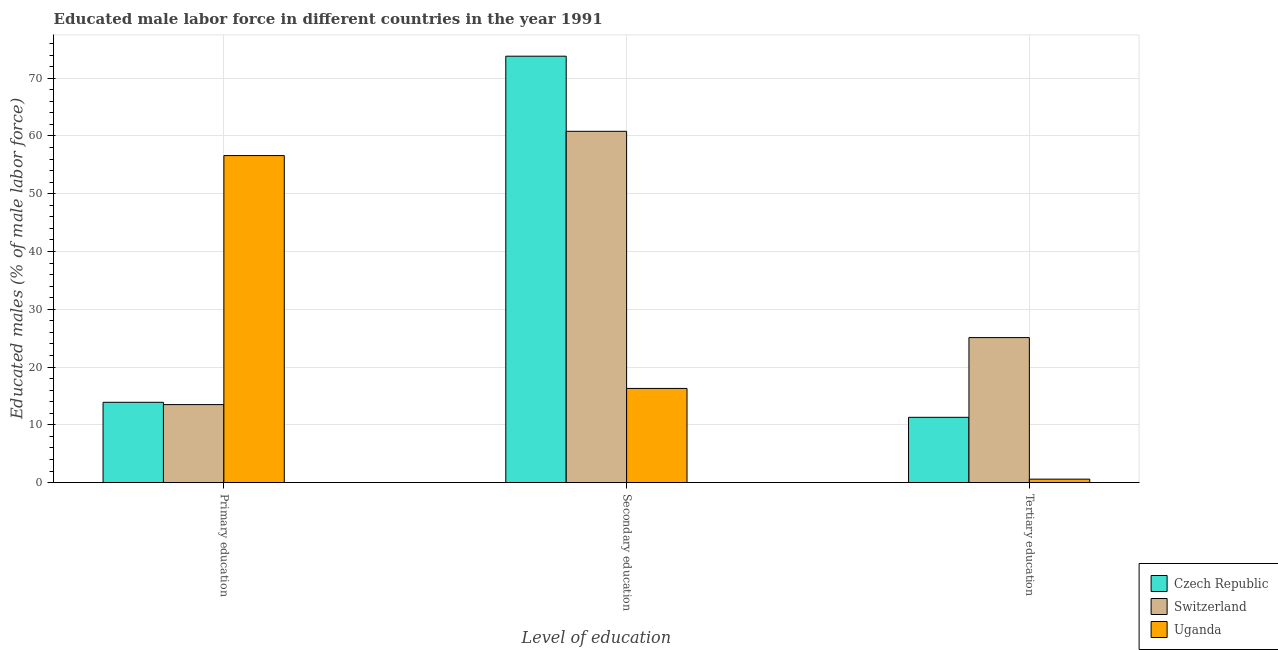Are the number of bars on each tick of the X-axis equal?
Ensure brevity in your answer.  Yes. How many bars are there on the 2nd tick from the right?
Give a very brief answer. 3. What is the label of the 2nd group of bars from the left?
Your answer should be very brief. Secondary education. What is the percentage of male labor force who received secondary education in Switzerland?
Ensure brevity in your answer.  60.8. Across all countries, what is the maximum percentage of male labor force who received tertiary education?
Offer a terse response. 25.1. Across all countries, what is the minimum percentage of male labor force who received tertiary education?
Make the answer very short. 0.6. In which country was the percentage of male labor force who received primary education maximum?
Offer a terse response. Uganda. In which country was the percentage of male labor force who received tertiary education minimum?
Your answer should be very brief. Uganda. What is the total percentage of male labor force who received primary education in the graph?
Give a very brief answer. 84. What is the difference between the percentage of male labor force who received primary education in Uganda and that in Switzerland?
Make the answer very short. 43.1. What is the difference between the percentage of male labor force who received secondary education in Switzerland and the percentage of male labor force who received tertiary education in Czech Republic?
Provide a short and direct response. 49.5. What is the average percentage of male labor force who received tertiary education per country?
Make the answer very short. 12.33. What is the difference between the percentage of male labor force who received secondary education and percentage of male labor force who received primary education in Uganda?
Provide a succinct answer. -40.3. In how many countries, is the percentage of male labor force who received secondary education greater than 6 %?
Your answer should be compact. 3. What is the ratio of the percentage of male labor force who received tertiary education in Czech Republic to that in Uganda?
Give a very brief answer. 18.83. Is the percentage of male labor force who received primary education in Uganda less than that in Czech Republic?
Ensure brevity in your answer.  No. What is the difference between the highest and the second highest percentage of male labor force who received secondary education?
Keep it short and to the point. 13. What is the difference between the highest and the lowest percentage of male labor force who received primary education?
Your answer should be compact. 43.1. Is the sum of the percentage of male labor force who received tertiary education in Uganda and Czech Republic greater than the maximum percentage of male labor force who received secondary education across all countries?
Your response must be concise. No. What does the 3rd bar from the left in Tertiary education represents?
Keep it short and to the point. Uganda. What does the 1st bar from the right in Primary education represents?
Your answer should be compact. Uganda. Is it the case that in every country, the sum of the percentage of male labor force who received primary education and percentage of male labor force who received secondary education is greater than the percentage of male labor force who received tertiary education?
Offer a terse response. Yes. How many bars are there?
Make the answer very short. 9. Are the values on the major ticks of Y-axis written in scientific E-notation?
Ensure brevity in your answer.  No. Does the graph contain grids?
Keep it short and to the point. Yes. Where does the legend appear in the graph?
Make the answer very short. Bottom right. How many legend labels are there?
Provide a succinct answer. 3. What is the title of the graph?
Offer a very short reply. Educated male labor force in different countries in the year 1991. Does "Euro area" appear as one of the legend labels in the graph?
Provide a succinct answer. No. What is the label or title of the X-axis?
Offer a very short reply. Level of education. What is the label or title of the Y-axis?
Your answer should be compact. Educated males (% of male labor force). What is the Educated males (% of male labor force) of Czech Republic in Primary education?
Offer a terse response. 13.9. What is the Educated males (% of male labor force) in Switzerland in Primary education?
Provide a short and direct response. 13.5. What is the Educated males (% of male labor force) of Uganda in Primary education?
Your answer should be very brief. 56.6. What is the Educated males (% of male labor force) in Czech Republic in Secondary education?
Your response must be concise. 73.8. What is the Educated males (% of male labor force) in Switzerland in Secondary education?
Make the answer very short. 60.8. What is the Educated males (% of male labor force) of Uganda in Secondary education?
Provide a short and direct response. 16.3. What is the Educated males (% of male labor force) of Czech Republic in Tertiary education?
Your response must be concise. 11.3. What is the Educated males (% of male labor force) in Switzerland in Tertiary education?
Make the answer very short. 25.1. What is the Educated males (% of male labor force) of Uganda in Tertiary education?
Ensure brevity in your answer.  0.6. Across all Level of education, what is the maximum Educated males (% of male labor force) of Czech Republic?
Provide a short and direct response. 73.8. Across all Level of education, what is the maximum Educated males (% of male labor force) in Switzerland?
Keep it short and to the point. 60.8. Across all Level of education, what is the maximum Educated males (% of male labor force) in Uganda?
Provide a short and direct response. 56.6. Across all Level of education, what is the minimum Educated males (% of male labor force) in Czech Republic?
Ensure brevity in your answer.  11.3. Across all Level of education, what is the minimum Educated males (% of male labor force) of Uganda?
Provide a succinct answer. 0.6. What is the total Educated males (% of male labor force) in Switzerland in the graph?
Your response must be concise. 99.4. What is the total Educated males (% of male labor force) in Uganda in the graph?
Offer a terse response. 73.5. What is the difference between the Educated males (% of male labor force) in Czech Republic in Primary education and that in Secondary education?
Your response must be concise. -59.9. What is the difference between the Educated males (% of male labor force) of Switzerland in Primary education and that in Secondary education?
Offer a terse response. -47.3. What is the difference between the Educated males (% of male labor force) of Uganda in Primary education and that in Secondary education?
Offer a very short reply. 40.3. What is the difference between the Educated males (% of male labor force) in Switzerland in Primary education and that in Tertiary education?
Provide a succinct answer. -11.6. What is the difference between the Educated males (% of male labor force) in Uganda in Primary education and that in Tertiary education?
Provide a short and direct response. 56. What is the difference between the Educated males (% of male labor force) in Czech Republic in Secondary education and that in Tertiary education?
Keep it short and to the point. 62.5. What is the difference between the Educated males (% of male labor force) in Switzerland in Secondary education and that in Tertiary education?
Keep it short and to the point. 35.7. What is the difference between the Educated males (% of male labor force) in Uganda in Secondary education and that in Tertiary education?
Give a very brief answer. 15.7. What is the difference between the Educated males (% of male labor force) in Czech Republic in Primary education and the Educated males (% of male labor force) in Switzerland in Secondary education?
Keep it short and to the point. -46.9. What is the difference between the Educated males (% of male labor force) in Switzerland in Primary education and the Educated males (% of male labor force) in Uganda in Secondary education?
Your answer should be very brief. -2.8. What is the difference between the Educated males (% of male labor force) of Czech Republic in Primary education and the Educated males (% of male labor force) of Switzerland in Tertiary education?
Your answer should be very brief. -11.2. What is the difference between the Educated males (% of male labor force) in Czech Republic in Secondary education and the Educated males (% of male labor force) in Switzerland in Tertiary education?
Offer a very short reply. 48.7. What is the difference between the Educated males (% of male labor force) of Czech Republic in Secondary education and the Educated males (% of male labor force) of Uganda in Tertiary education?
Provide a succinct answer. 73.2. What is the difference between the Educated males (% of male labor force) in Switzerland in Secondary education and the Educated males (% of male labor force) in Uganda in Tertiary education?
Keep it short and to the point. 60.2. What is the average Educated males (% of male labor force) of Czech Republic per Level of education?
Ensure brevity in your answer.  33. What is the average Educated males (% of male labor force) of Switzerland per Level of education?
Provide a short and direct response. 33.13. What is the difference between the Educated males (% of male labor force) of Czech Republic and Educated males (% of male labor force) of Switzerland in Primary education?
Provide a short and direct response. 0.4. What is the difference between the Educated males (% of male labor force) in Czech Republic and Educated males (% of male labor force) in Uganda in Primary education?
Keep it short and to the point. -42.7. What is the difference between the Educated males (% of male labor force) of Switzerland and Educated males (% of male labor force) of Uganda in Primary education?
Provide a short and direct response. -43.1. What is the difference between the Educated males (% of male labor force) in Czech Republic and Educated males (% of male labor force) in Switzerland in Secondary education?
Provide a short and direct response. 13. What is the difference between the Educated males (% of male labor force) of Czech Republic and Educated males (% of male labor force) of Uganda in Secondary education?
Provide a short and direct response. 57.5. What is the difference between the Educated males (% of male labor force) in Switzerland and Educated males (% of male labor force) in Uganda in Secondary education?
Give a very brief answer. 44.5. What is the difference between the Educated males (% of male labor force) in Czech Republic and Educated males (% of male labor force) in Switzerland in Tertiary education?
Your response must be concise. -13.8. What is the ratio of the Educated males (% of male labor force) of Czech Republic in Primary education to that in Secondary education?
Provide a succinct answer. 0.19. What is the ratio of the Educated males (% of male labor force) of Switzerland in Primary education to that in Secondary education?
Offer a very short reply. 0.22. What is the ratio of the Educated males (% of male labor force) in Uganda in Primary education to that in Secondary education?
Give a very brief answer. 3.47. What is the ratio of the Educated males (% of male labor force) in Czech Republic in Primary education to that in Tertiary education?
Keep it short and to the point. 1.23. What is the ratio of the Educated males (% of male labor force) in Switzerland in Primary education to that in Tertiary education?
Your response must be concise. 0.54. What is the ratio of the Educated males (% of male labor force) of Uganda in Primary education to that in Tertiary education?
Provide a succinct answer. 94.33. What is the ratio of the Educated males (% of male labor force) in Czech Republic in Secondary education to that in Tertiary education?
Make the answer very short. 6.53. What is the ratio of the Educated males (% of male labor force) in Switzerland in Secondary education to that in Tertiary education?
Your answer should be very brief. 2.42. What is the ratio of the Educated males (% of male labor force) in Uganda in Secondary education to that in Tertiary education?
Offer a terse response. 27.17. What is the difference between the highest and the second highest Educated males (% of male labor force) of Czech Republic?
Ensure brevity in your answer.  59.9. What is the difference between the highest and the second highest Educated males (% of male labor force) in Switzerland?
Your answer should be compact. 35.7. What is the difference between the highest and the second highest Educated males (% of male labor force) in Uganda?
Offer a terse response. 40.3. What is the difference between the highest and the lowest Educated males (% of male labor force) in Czech Republic?
Offer a terse response. 62.5. What is the difference between the highest and the lowest Educated males (% of male labor force) of Switzerland?
Keep it short and to the point. 47.3. What is the difference between the highest and the lowest Educated males (% of male labor force) of Uganda?
Keep it short and to the point. 56. 